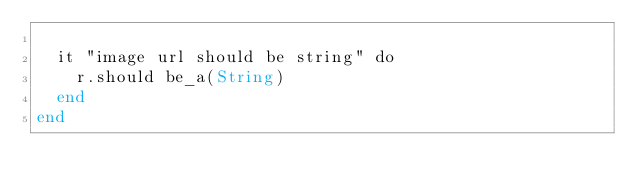<code> <loc_0><loc_0><loc_500><loc_500><_Crystal_>
  it "image url should be string" do
    r.should be_a(String)
  end
end
</code> 